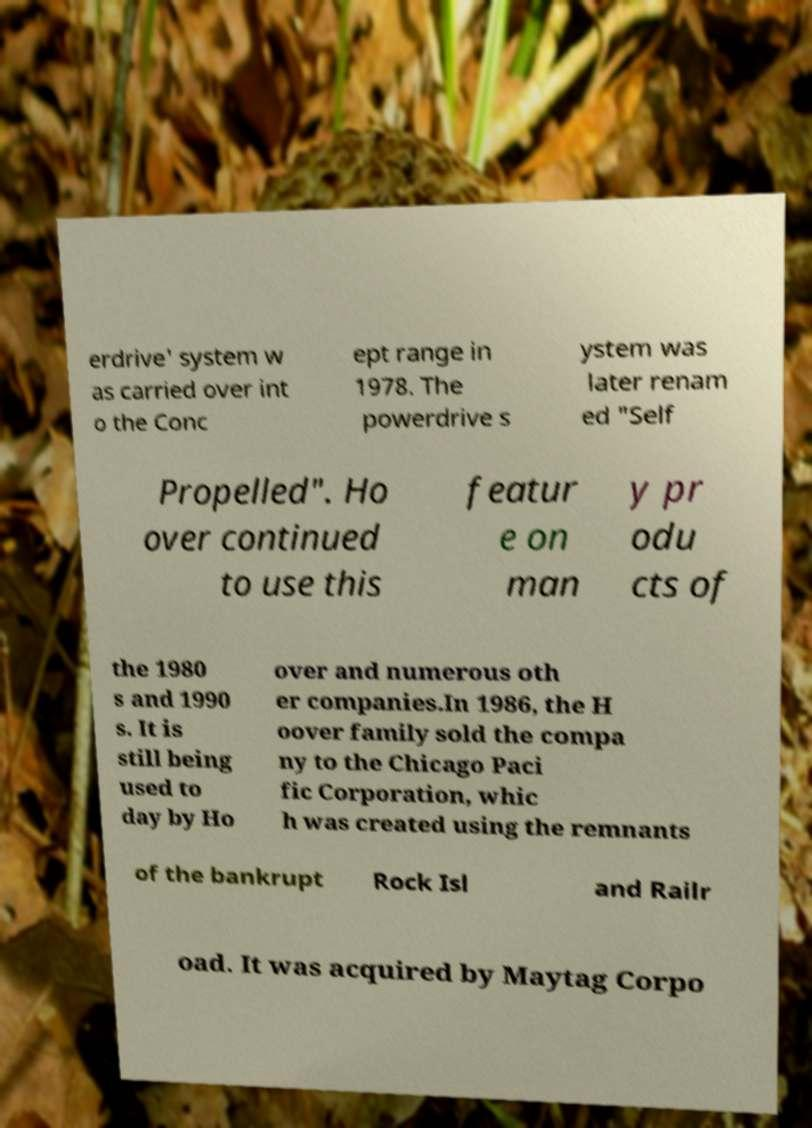Please read and relay the text visible in this image. What does it say? erdrive' system w as carried over int o the Conc ept range in 1978. The powerdrive s ystem was later renam ed "Self Propelled". Ho over continued to use this featur e on man y pr odu cts of the 1980 s and 1990 s. It is still being used to day by Ho over and numerous oth er companies.In 1986, the H oover family sold the compa ny to the Chicago Paci fic Corporation, whic h was created using the remnants of the bankrupt Rock Isl and Railr oad. It was acquired by Maytag Corpo 